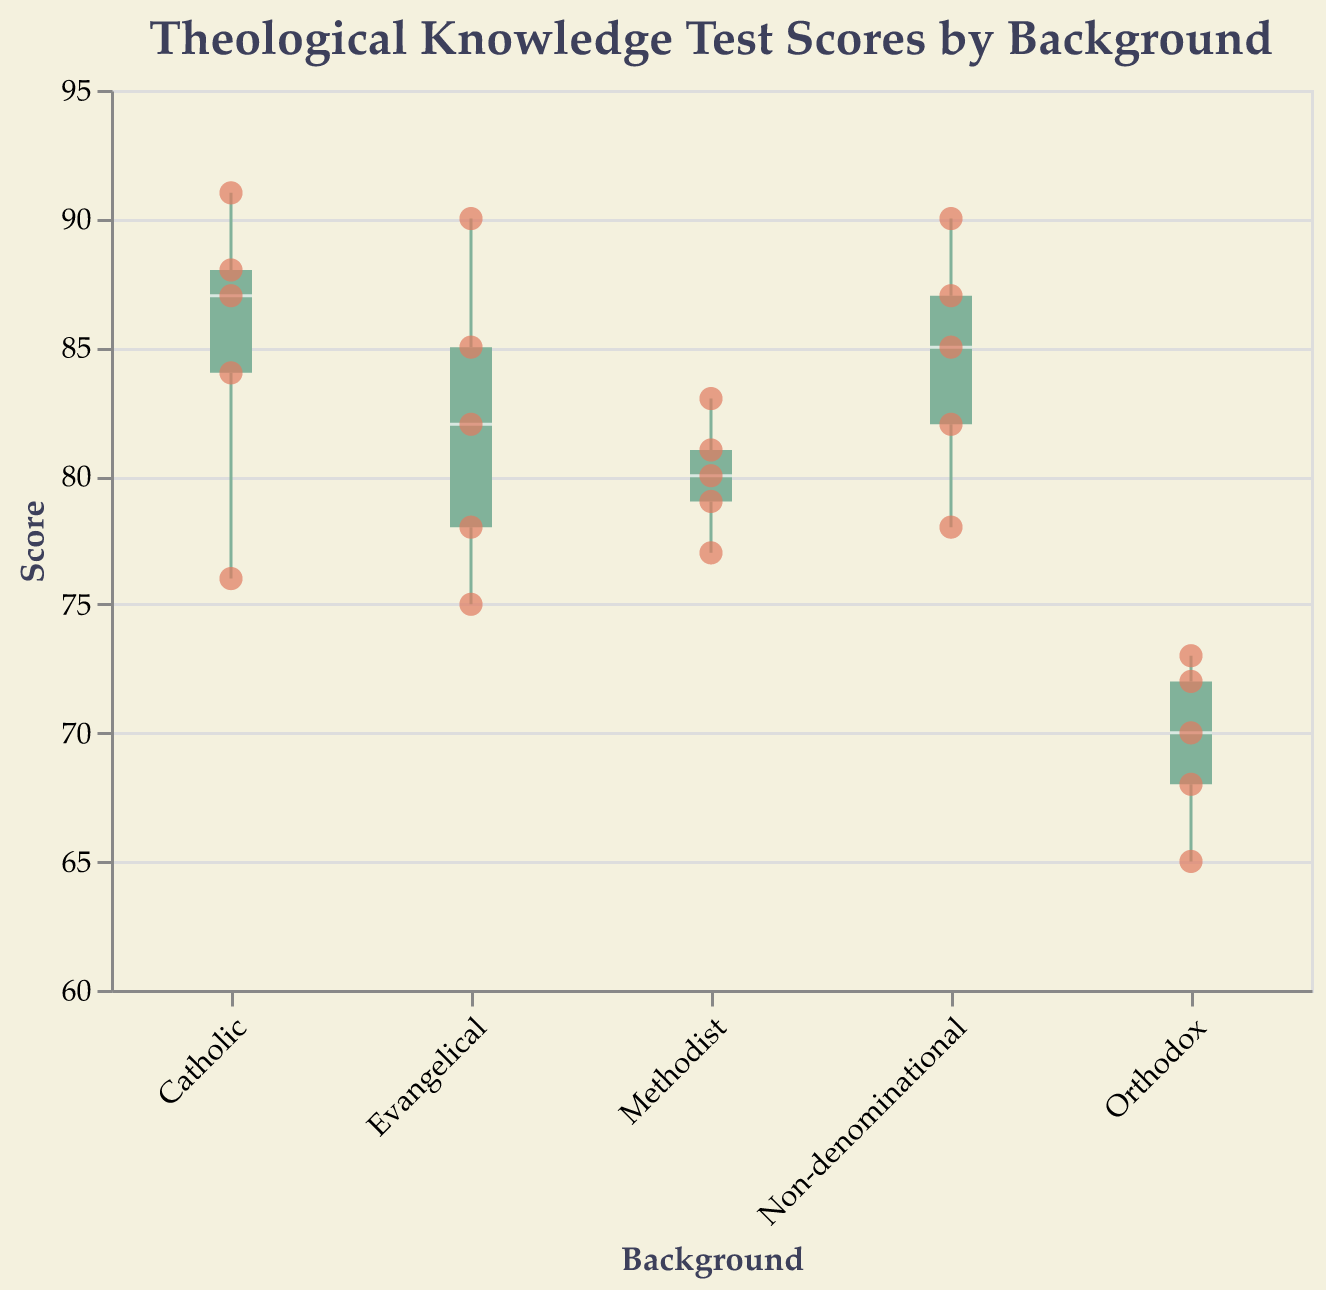What is the median score for Evangelical students? The median is the middle value of the Scores for Evangelical students when they are ordered. The scores for Evangelical students are 75, 78, 82, 85, and 90. The median is the middle value, 82.
Answer: 82 Which group has the lowest median score? By comparing the medians of all groups, the Orthodox group has the lowest median score, which is evident from their box plot being positioned lower than others.
Answer: Orthodox How many data points are there for Catholic students? By counting the scatter points for the Catholic group on the plot, there are 5 data points.
Answer: 5 What is the range of scores for Non-denominational students? The range is the difference between the maximum and minimum scores. The maximum score for Non-denominational students is 90 and the minimum is 78, so the range is 90 - 78 = 12.
Answer: 12 What is the interquartile range (IQR) for Methodist students? The IQR is the range between the first quartile (25th percentile) and the third quartile (75th percentile). For Methodist students, the first quartile is 77 and the third quartile is 81, so the IQR is 81 - 77 = 4.
Answer: 4 Which group has the highest individual score and what is that score? The highest individual score among all groups is 91, and it belongs to a Catholic student.
Answer: Catholic, 91 What is the difference between the median scores of Evangelical and Catholic students? The median score for Evangelical students is 82, and for Catholic students, it is 87. The difference is 87 - 82 = 5.
Answer: 5 How does the variation in scores compare between Orthodox and Non-denominational students? Orthodox students have a wider variation in scores (from 65 to 73) compared to Non-denominational students (from 78 to 90). This can be seen from the spread of their box plot and whiskers.
Answer: Orthodox scores have a wider variation What is the score of the lowest-scoring student and which group do they belong to? The lowest-scoring student has a score of 65, and they belong to the Orthodox group.
Answer: 65, Orthodox How many students scored above 85 in total? By counting the scatter points above the 85 mark across all groups, there are 6 students who scored above 85.
Answer: 6 